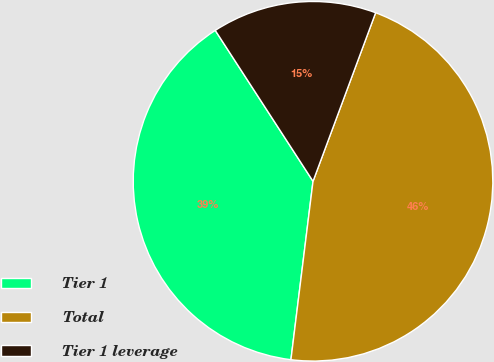Convert chart to OTSL. <chart><loc_0><loc_0><loc_500><loc_500><pie_chart><fcel>Tier 1<fcel>Total<fcel>Tier 1 leverage<nl><fcel>38.89%<fcel>46.3%<fcel>14.81%<nl></chart> 